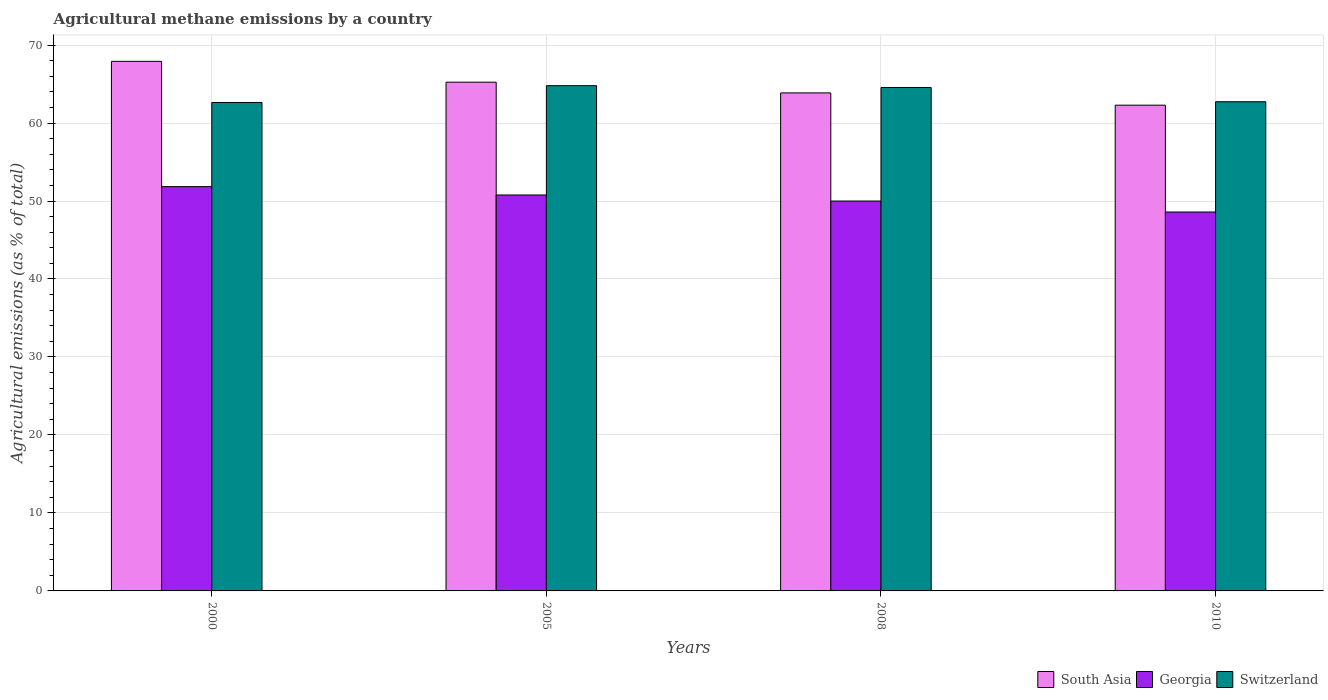How many different coloured bars are there?
Keep it short and to the point. 3. How many groups of bars are there?
Provide a short and direct response. 4. Are the number of bars on each tick of the X-axis equal?
Provide a succinct answer. Yes. How many bars are there on the 1st tick from the right?
Provide a short and direct response. 3. In how many cases, is the number of bars for a given year not equal to the number of legend labels?
Make the answer very short. 0. What is the amount of agricultural methane emitted in Georgia in 2008?
Offer a very short reply. 50. Across all years, what is the maximum amount of agricultural methane emitted in South Asia?
Offer a terse response. 67.91. Across all years, what is the minimum amount of agricultural methane emitted in South Asia?
Offer a terse response. 62.29. In which year was the amount of agricultural methane emitted in Switzerland minimum?
Offer a terse response. 2000. What is the total amount of agricultural methane emitted in Switzerland in the graph?
Provide a short and direct response. 254.71. What is the difference between the amount of agricultural methane emitted in Switzerland in 2000 and that in 2005?
Your answer should be compact. -2.15. What is the difference between the amount of agricultural methane emitted in South Asia in 2000 and the amount of agricultural methane emitted in Georgia in 2010?
Your answer should be compact. 19.32. What is the average amount of agricultural methane emitted in South Asia per year?
Your answer should be compact. 64.82. In the year 2010, what is the difference between the amount of agricultural methane emitted in Georgia and amount of agricultural methane emitted in Switzerland?
Ensure brevity in your answer.  -14.14. In how many years, is the amount of agricultural methane emitted in Switzerland greater than 54 %?
Offer a very short reply. 4. What is the ratio of the amount of agricultural methane emitted in Georgia in 2000 to that in 2008?
Your response must be concise. 1.04. What is the difference between the highest and the second highest amount of agricultural methane emitted in Switzerland?
Your answer should be very brief. 0.23. What is the difference between the highest and the lowest amount of agricultural methane emitted in South Asia?
Your response must be concise. 5.62. What does the 3rd bar from the left in 2010 represents?
Your answer should be very brief. Switzerland. What does the 2nd bar from the right in 2005 represents?
Offer a very short reply. Georgia. Are the values on the major ticks of Y-axis written in scientific E-notation?
Keep it short and to the point. No. Does the graph contain grids?
Provide a succinct answer. Yes. Where does the legend appear in the graph?
Offer a very short reply. Bottom right. What is the title of the graph?
Give a very brief answer. Agricultural methane emissions by a country. What is the label or title of the X-axis?
Offer a terse response. Years. What is the label or title of the Y-axis?
Ensure brevity in your answer.  Agricultural emissions (as % of total). What is the Agricultural emissions (as % of total) of South Asia in 2000?
Ensure brevity in your answer.  67.91. What is the Agricultural emissions (as % of total) of Georgia in 2000?
Give a very brief answer. 51.84. What is the Agricultural emissions (as % of total) of Switzerland in 2000?
Make the answer very short. 62.63. What is the Agricultural emissions (as % of total) in South Asia in 2005?
Ensure brevity in your answer.  65.24. What is the Agricultural emissions (as % of total) of Georgia in 2005?
Give a very brief answer. 50.77. What is the Agricultural emissions (as % of total) in Switzerland in 2005?
Provide a succinct answer. 64.79. What is the Agricultural emissions (as % of total) of South Asia in 2008?
Provide a short and direct response. 63.86. What is the Agricultural emissions (as % of total) of Georgia in 2008?
Your answer should be very brief. 50. What is the Agricultural emissions (as % of total) in Switzerland in 2008?
Keep it short and to the point. 64.56. What is the Agricultural emissions (as % of total) in South Asia in 2010?
Offer a terse response. 62.29. What is the Agricultural emissions (as % of total) in Georgia in 2010?
Make the answer very short. 48.59. What is the Agricultural emissions (as % of total) of Switzerland in 2010?
Your answer should be compact. 62.73. Across all years, what is the maximum Agricultural emissions (as % of total) in South Asia?
Offer a terse response. 67.91. Across all years, what is the maximum Agricultural emissions (as % of total) in Georgia?
Make the answer very short. 51.84. Across all years, what is the maximum Agricultural emissions (as % of total) in Switzerland?
Your answer should be very brief. 64.79. Across all years, what is the minimum Agricultural emissions (as % of total) of South Asia?
Keep it short and to the point. 62.29. Across all years, what is the minimum Agricultural emissions (as % of total) of Georgia?
Provide a succinct answer. 48.59. Across all years, what is the minimum Agricultural emissions (as % of total) of Switzerland?
Offer a very short reply. 62.63. What is the total Agricultural emissions (as % of total) of South Asia in the graph?
Offer a terse response. 259.29. What is the total Agricultural emissions (as % of total) of Georgia in the graph?
Give a very brief answer. 201.2. What is the total Agricultural emissions (as % of total) in Switzerland in the graph?
Your answer should be very brief. 254.71. What is the difference between the Agricultural emissions (as % of total) in South Asia in 2000 and that in 2005?
Your answer should be very brief. 2.67. What is the difference between the Agricultural emissions (as % of total) in Georgia in 2000 and that in 2005?
Give a very brief answer. 1.07. What is the difference between the Agricultural emissions (as % of total) of Switzerland in 2000 and that in 2005?
Give a very brief answer. -2.15. What is the difference between the Agricultural emissions (as % of total) in South Asia in 2000 and that in 2008?
Your answer should be compact. 4.04. What is the difference between the Agricultural emissions (as % of total) of Georgia in 2000 and that in 2008?
Your answer should be very brief. 1.85. What is the difference between the Agricultural emissions (as % of total) of Switzerland in 2000 and that in 2008?
Keep it short and to the point. -1.92. What is the difference between the Agricultural emissions (as % of total) in South Asia in 2000 and that in 2010?
Your answer should be compact. 5.62. What is the difference between the Agricultural emissions (as % of total) of Georgia in 2000 and that in 2010?
Your response must be concise. 3.26. What is the difference between the Agricultural emissions (as % of total) of Switzerland in 2000 and that in 2010?
Provide a succinct answer. -0.1. What is the difference between the Agricultural emissions (as % of total) in South Asia in 2005 and that in 2008?
Keep it short and to the point. 1.37. What is the difference between the Agricultural emissions (as % of total) in Georgia in 2005 and that in 2008?
Provide a succinct answer. 0.77. What is the difference between the Agricultural emissions (as % of total) in Switzerland in 2005 and that in 2008?
Offer a very short reply. 0.23. What is the difference between the Agricultural emissions (as % of total) in South Asia in 2005 and that in 2010?
Your answer should be very brief. 2.95. What is the difference between the Agricultural emissions (as % of total) in Georgia in 2005 and that in 2010?
Your response must be concise. 2.18. What is the difference between the Agricultural emissions (as % of total) of Switzerland in 2005 and that in 2010?
Your response must be concise. 2.06. What is the difference between the Agricultural emissions (as % of total) in South Asia in 2008 and that in 2010?
Your answer should be compact. 1.58. What is the difference between the Agricultural emissions (as % of total) of Georgia in 2008 and that in 2010?
Make the answer very short. 1.41. What is the difference between the Agricultural emissions (as % of total) in Switzerland in 2008 and that in 2010?
Give a very brief answer. 1.83. What is the difference between the Agricultural emissions (as % of total) in South Asia in 2000 and the Agricultural emissions (as % of total) in Georgia in 2005?
Ensure brevity in your answer.  17.13. What is the difference between the Agricultural emissions (as % of total) in South Asia in 2000 and the Agricultural emissions (as % of total) in Switzerland in 2005?
Ensure brevity in your answer.  3.12. What is the difference between the Agricultural emissions (as % of total) of Georgia in 2000 and the Agricultural emissions (as % of total) of Switzerland in 2005?
Your answer should be compact. -12.94. What is the difference between the Agricultural emissions (as % of total) in South Asia in 2000 and the Agricultural emissions (as % of total) in Georgia in 2008?
Keep it short and to the point. 17.91. What is the difference between the Agricultural emissions (as % of total) of South Asia in 2000 and the Agricultural emissions (as % of total) of Switzerland in 2008?
Keep it short and to the point. 3.35. What is the difference between the Agricultural emissions (as % of total) in Georgia in 2000 and the Agricultural emissions (as % of total) in Switzerland in 2008?
Give a very brief answer. -12.71. What is the difference between the Agricultural emissions (as % of total) in South Asia in 2000 and the Agricultural emissions (as % of total) in Georgia in 2010?
Make the answer very short. 19.32. What is the difference between the Agricultural emissions (as % of total) of South Asia in 2000 and the Agricultural emissions (as % of total) of Switzerland in 2010?
Provide a succinct answer. 5.18. What is the difference between the Agricultural emissions (as % of total) of Georgia in 2000 and the Agricultural emissions (as % of total) of Switzerland in 2010?
Your response must be concise. -10.89. What is the difference between the Agricultural emissions (as % of total) in South Asia in 2005 and the Agricultural emissions (as % of total) in Georgia in 2008?
Provide a succinct answer. 15.24. What is the difference between the Agricultural emissions (as % of total) in South Asia in 2005 and the Agricultural emissions (as % of total) in Switzerland in 2008?
Give a very brief answer. 0.68. What is the difference between the Agricultural emissions (as % of total) in Georgia in 2005 and the Agricultural emissions (as % of total) in Switzerland in 2008?
Keep it short and to the point. -13.79. What is the difference between the Agricultural emissions (as % of total) of South Asia in 2005 and the Agricultural emissions (as % of total) of Georgia in 2010?
Provide a succinct answer. 16.65. What is the difference between the Agricultural emissions (as % of total) in South Asia in 2005 and the Agricultural emissions (as % of total) in Switzerland in 2010?
Offer a very short reply. 2.51. What is the difference between the Agricultural emissions (as % of total) in Georgia in 2005 and the Agricultural emissions (as % of total) in Switzerland in 2010?
Provide a short and direct response. -11.96. What is the difference between the Agricultural emissions (as % of total) of South Asia in 2008 and the Agricultural emissions (as % of total) of Georgia in 2010?
Offer a terse response. 15.27. What is the difference between the Agricultural emissions (as % of total) of South Asia in 2008 and the Agricultural emissions (as % of total) of Switzerland in 2010?
Offer a terse response. 1.13. What is the difference between the Agricultural emissions (as % of total) in Georgia in 2008 and the Agricultural emissions (as % of total) in Switzerland in 2010?
Your response must be concise. -12.73. What is the average Agricultural emissions (as % of total) of South Asia per year?
Your response must be concise. 64.82. What is the average Agricultural emissions (as % of total) of Georgia per year?
Your answer should be compact. 50.3. What is the average Agricultural emissions (as % of total) in Switzerland per year?
Your answer should be very brief. 63.68. In the year 2000, what is the difference between the Agricultural emissions (as % of total) of South Asia and Agricultural emissions (as % of total) of Georgia?
Provide a short and direct response. 16.06. In the year 2000, what is the difference between the Agricultural emissions (as % of total) of South Asia and Agricultural emissions (as % of total) of Switzerland?
Your response must be concise. 5.27. In the year 2000, what is the difference between the Agricultural emissions (as % of total) of Georgia and Agricultural emissions (as % of total) of Switzerland?
Make the answer very short. -10.79. In the year 2005, what is the difference between the Agricultural emissions (as % of total) of South Asia and Agricultural emissions (as % of total) of Georgia?
Give a very brief answer. 14.46. In the year 2005, what is the difference between the Agricultural emissions (as % of total) of South Asia and Agricultural emissions (as % of total) of Switzerland?
Make the answer very short. 0.45. In the year 2005, what is the difference between the Agricultural emissions (as % of total) in Georgia and Agricultural emissions (as % of total) in Switzerland?
Keep it short and to the point. -14.02. In the year 2008, what is the difference between the Agricultural emissions (as % of total) in South Asia and Agricultural emissions (as % of total) in Georgia?
Offer a terse response. 13.87. In the year 2008, what is the difference between the Agricultural emissions (as % of total) of South Asia and Agricultural emissions (as % of total) of Switzerland?
Your answer should be compact. -0.7. In the year 2008, what is the difference between the Agricultural emissions (as % of total) in Georgia and Agricultural emissions (as % of total) in Switzerland?
Your answer should be compact. -14.56. In the year 2010, what is the difference between the Agricultural emissions (as % of total) of South Asia and Agricultural emissions (as % of total) of Georgia?
Offer a very short reply. 13.7. In the year 2010, what is the difference between the Agricultural emissions (as % of total) of South Asia and Agricultural emissions (as % of total) of Switzerland?
Offer a very short reply. -0.44. In the year 2010, what is the difference between the Agricultural emissions (as % of total) of Georgia and Agricultural emissions (as % of total) of Switzerland?
Your answer should be very brief. -14.14. What is the ratio of the Agricultural emissions (as % of total) in South Asia in 2000 to that in 2005?
Your answer should be compact. 1.04. What is the ratio of the Agricultural emissions (as % of total) of Georgia in 2000 to that in 2005?
Offer a very short reply. 1.02. What is the ratio of the Agricultural emissions (as % of total) in Switzerland in 2000 to that in 2005?
Keep it short and to the point. 0.97. What is the ratio of the Agricultural emissions (as % of total) in South Asia in 2000 to that in 2008?
Offer a terse response. 1.06. What is the ratio of the Agricultural emissions (as % of total) in Georgia in 2000 to that in 2008?
Offer a very short reply. 1.04. What is the ratio of the Agricultural emissions (as % of total) of Switzerland in 2000 to that in 2008?
Ensure brevity in your answer.  0.97. What is the ratio of the Agricultural emissions (as % of total) in South Asia in 2000 to that in 2010?
Provide a short and direct response. 1.09. What is the ratio of the Agricultural emissions (as % of total) of Georgia in 2000 to that in 2010?
Provide a succinct answer. 1.07. What is the ratio of the Agricultural emissions (as % of total) in Switzerland in 2000 to that in 2010?
Provide a succinct answer. 1. What is the ratio of the Agricultural emissions (as % of total) of South Asia in 2005 to that in 2008?
Your answer should be compact. 1.02. What is the ratio of the Agricultural emissions (as % of total) in Georgia in 2005 to that in 2008?
Offer a very short reply. 1.02. What is the ratio of the Agricultural emissions (as % of total) in Switzerland in 2005 to that in 2008?
Ensure brevity in your answer.  1. What is the ratio of the Agricultural emissions (as % of total) in South Asia in 2005 to that in 2010?
Keep it short and to the point. 1.05. What is the ratio of the Agricultural emissions (as % of total) of Georgia in 2005 to that in 2010?
Offer a very short reply. 1.04. What is the ratio of the Agricultural emissions (as % of total) of Switzerland in 2005 to that in 2010?
Your answer should be compact. 1.03. What is the ratio of the Agricultural emissions (as % of total) of South Asia in 2008 to that in 2010?
Offer a terse response. 1.03. What is the ratio of the Agricultural emissions (as % of total) in Switzerland in 2008 to that in 2010?
Ensure brevity in your answer.  1.03. What is the difference between the highest and the second highest Agricultural emissions (as % of total) of South Asia?
Offer a very short reply. 2.67. What is the difference between the highest and the second highest Agricultural emissions (as % of total) of Georgia?
Make the answer very short. 1.07. What is the difference between the highest and the second highest Agricultural emissions (as % of total) in Switzerland?
Provide a short and direct response. 0.23. What is the difference between the highest and the lowest Agricultural emissions (as % of total) of South Asia?
Give a very brief answer. 5.62. What is the difference between the highest and the lowest Agricultural emissions (as % of total) in Georgia?
Ensure brevity in your answer.  3.26. What is the difference between the highest and the lowest Agricultural emissions (as % of total) in Switzerland?
Give a very brief answer. 2.15. 